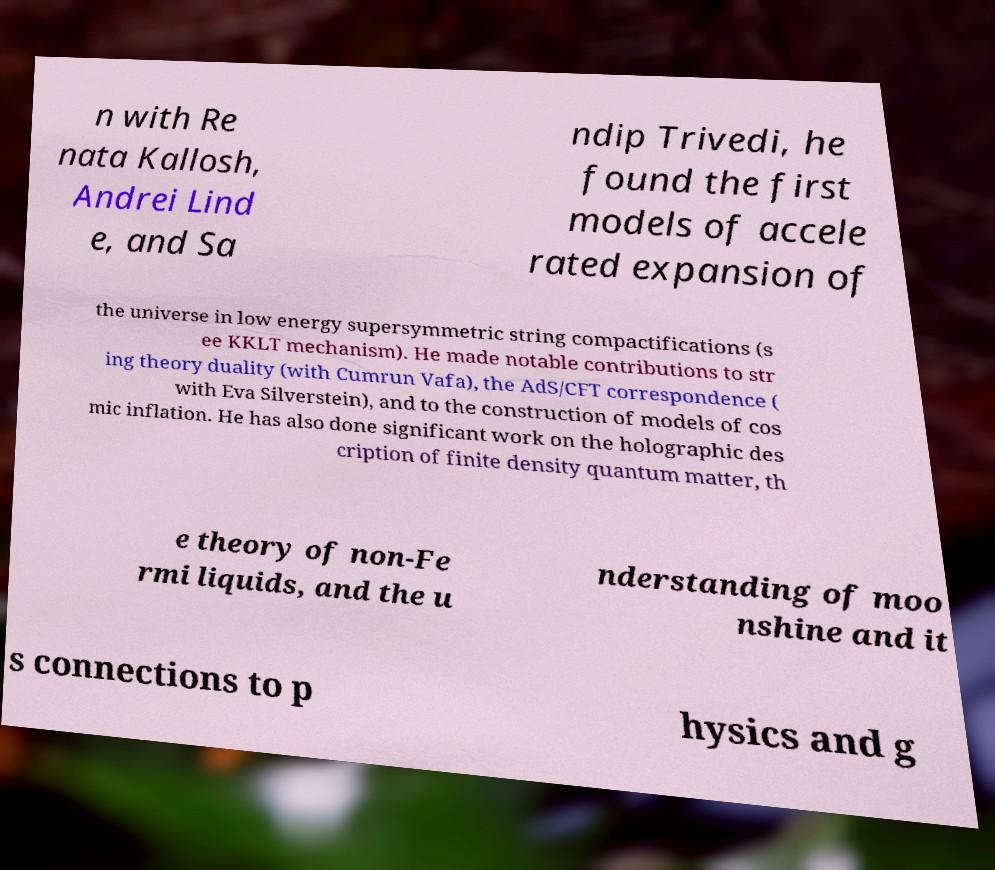There's text embedded in this image that I need extracted. Can you transcribe it verbatim? n with Re nata Kallosh, Andrei Lind e, and Sa ndip Trivedi, he found the first models of accele rated expansion of the universe in low energy supersymmetric string compactifications (s ee KKLT mechanism). He made notable contributions to str ing theory duality (with Cumrun Vafa), the AdS/CFT correspondence ( with Eva Silverstein), and to the construction of models of cos mic inflation. He has also done significant work on the holographic des cription of finite density quantum matter, th e theory of non-Fe rmi liquids, and the u nderstanding of moo nshine and it s connections to p hysics and g 